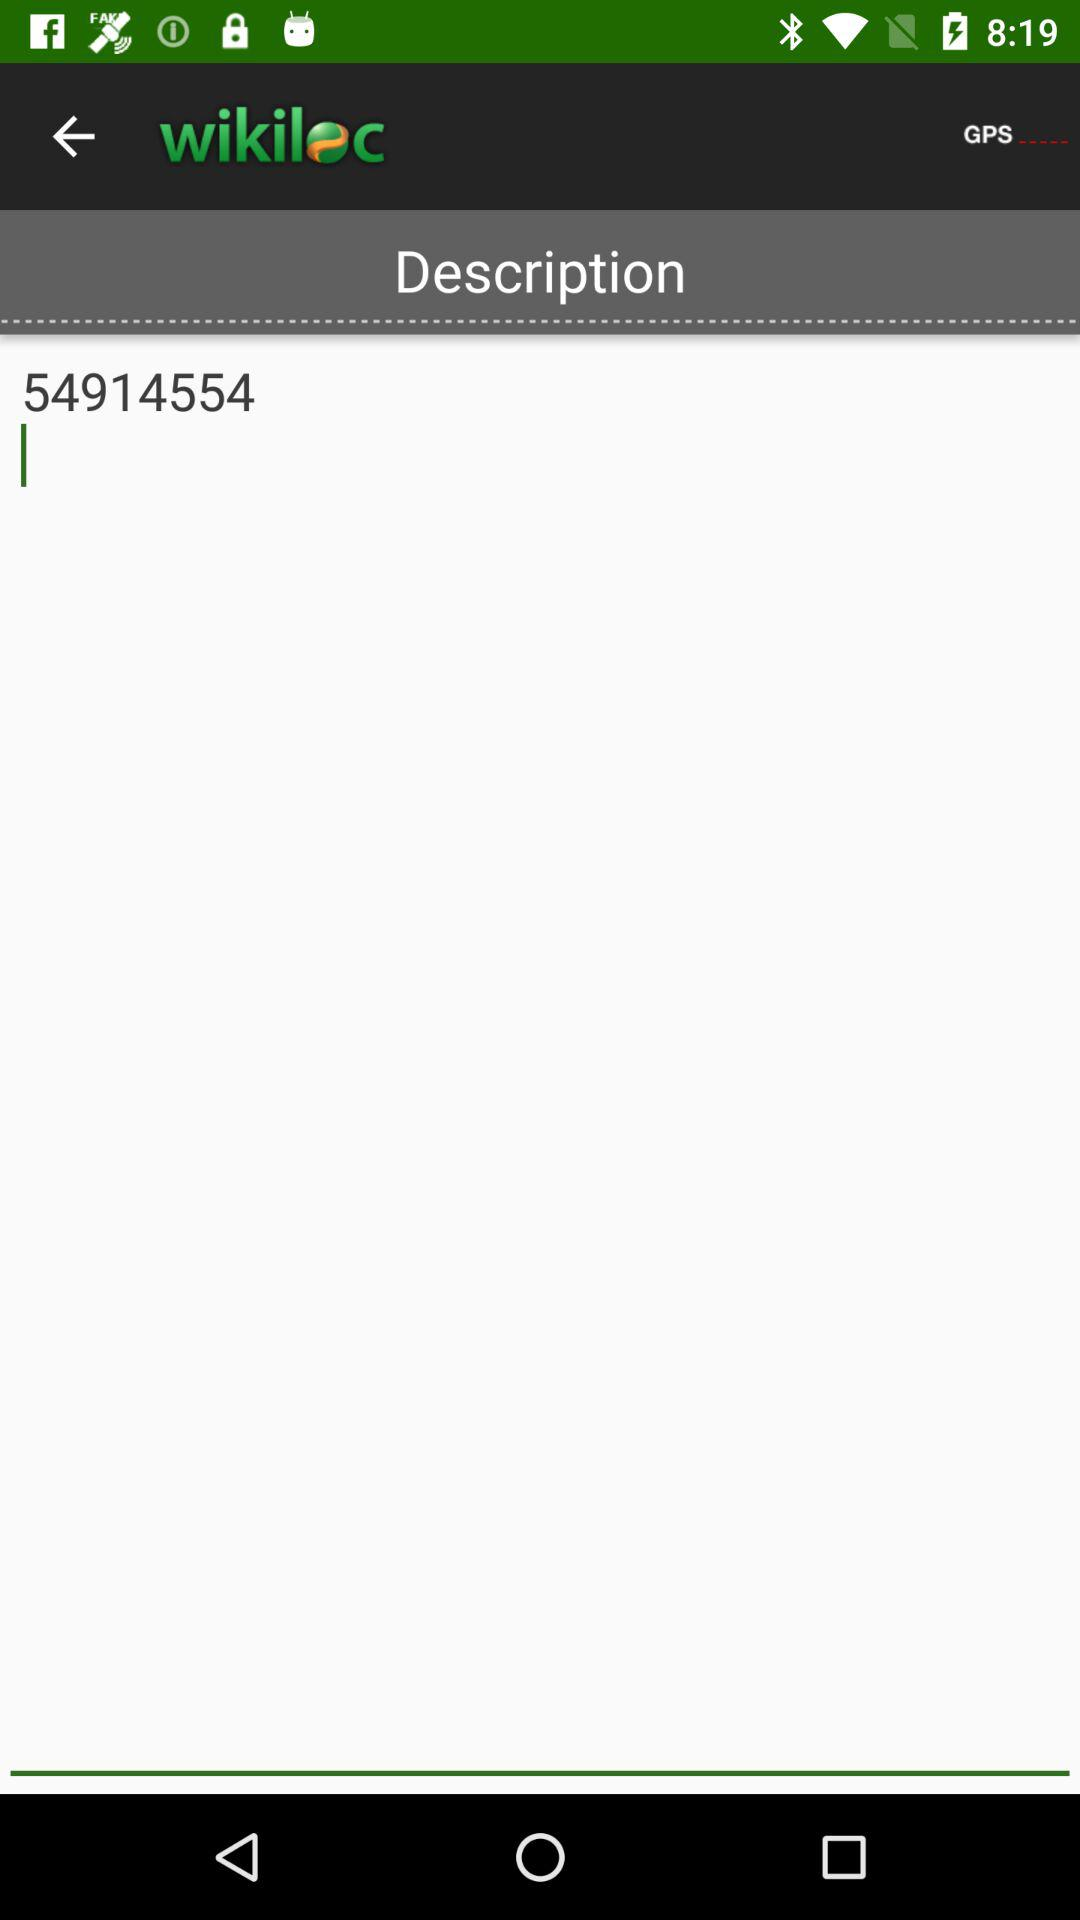What is the application name? The application name is "wikiloc". 